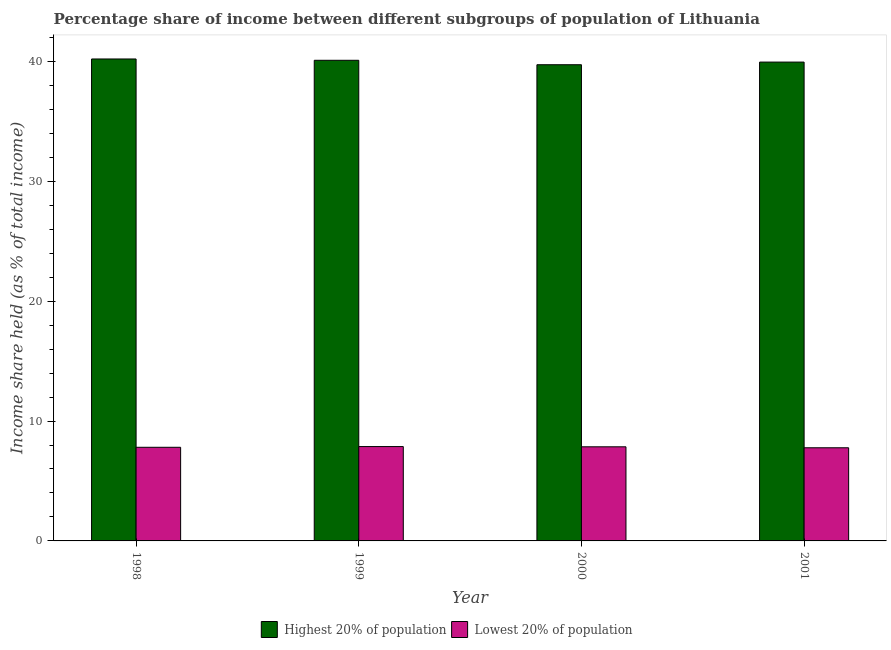How many different coloured bars are there?
Provide a succinct answer. 2. Are the number of bars per tick equal to the number of legend labels?
Make the answer very short. Yes. How many bars are there on the 4th tick from the left?
Give a very brief answer. 2. What is the label of the 2nd group of bars from the left?
Offer a very short reply. 1999. What is the income share held by highest 20% of the population in 1998?
Provide a succinct answer. 40.2. Across all years, what is the maximum income share held by lowest 20% of the population?
Your response must be concise. 7.87. Across all years, what is the minimum income share held by highest 20% of the population?
Make the answer very short. 39.72. In which year was the income share held by lowest 20% of the population maximum?
Keep it short and to the point. 1999. In which year was the income share held by highest 20% of the population minimum?
Make the answer very short. 2000. What is the total income share held by lowest 20% of the population in the graph?
Your answer should be compact. 31.3. What is the difference between the income share held by highest 20% of the population in 1999 and that in 2000?
Give a very brief answer. 0.37. What is the difference between the income share held by highest 20% of the population in 1998 and the income share held by lowest 20% of the population in 2000?
Give a very brief answer. 0.48. What is the average income share held by lowest 20% of the population per year?
Provide a succinct answer. 7.83. In how many years, is the income share held by highest 20% of the population greater than 34 %?
Ensure brevity in your answer.  4. What is the ratio of the income share held by highest 20% of the population in 1998 to that in 1999?
Offer a very short reply. 1. What is the difference between the highest and the second highest income share held by lowest 20% of the population?
Your response must be concise. 0.02. What is the difference between the highest and the lowest income share held by highest 20% of the population?
Give a very brief answer. 0.48. In how many years, is the income share held by lowest 20% of the population greater than the average income share held by lowest 20% of the population taken over all years?
Provide a succinct answer. 2. What does the 1st bar from the left in 2000 represents?
Your answer should be compact. Highest 20% of population. What does the 2nd bar from the right in 2000 represents?
Provide a succinct answer. Highest 20% of population. How many bars are there?
Your response must be concise. 8. Are all the bars in the graph horizontal?
Keep it short and to the point. No. How many years are there in the graph?
Your answer should be compact. 4. Where does the legend appear in the graph?
Provide a succinct answer. Bottom center. How many legend labels are there?
Offer a terse response. 2. What is the title of the graph?
Your answer should be compact. Percentage share of income between different subgroups of population of Lithuania. Does "Merchandise imports" appear as one of the legend labels in the graph?
Offer a very short reply. No. What is the label or title of the Y-axis?
Your answer should be very brief. Income share held (as % of total income). What is the Income share held (as % of total income) in Highest 20% of population in 1998?
Your answer should be compact. 40.2. What is the Income share held (as % of total income) of Lowest 20% of population in 1998?
Ensure brevity in your answer.  7.81. What is the Income share held (as % of total income) of Highest 20% of population in 1999?
Ensure brevity in your answer.  40.09. What is the Income share held (as % of total income) of Lowest 20% of population in 1999?
Your answer should be very brief. 7.87. What is the Income share held (as % of total income) in Highest 20% of population in 2000?
Your response must be concise. 39.72. What is the Income share held (as % of total income) in Lowest 20% of population in 2000?
Keep it short and to the point. 7.85. What is the Income share held (as % of total income) in Highest 20% of population in 2001?
Ensure brevity in your answer.  39.94. What is the Income share held (as % of total income) in Lowest 20% of population in 2001?
Offer a terse response. 7.77. Across all years, what is the maximum Income share held (as % of total income) in Highest 20% of population?
Your answer should be compact. 40.2. Across all years, what is the maximum Income share held (as % of total income) of Lowest 20% of population?
Keep it short and to the point. 7.87. Across all years, what is the minimum Income share held (as % of total income) of Highest 20% of population?
Ensure brevity in your answer.  39.72. Across all years, what is the minimum Income share held (as % of total income) of Lowest 20% of population?
Provide a succinct answer. 7.77. What is the total Income share held (as % of total income) in Highest 20% of population in the graph?
Your response must be concise. 159.95. What is the total Income share held (as % of total income) of Lowest 20% of population in the graph?
Provide a succinct answer. 31.3. What is the difference between the Income share held (as % of total income) in Highest 20% of population in 1998 and that in 1999?
Your answer should be very brief. 0.11. What is the difference between the Income share held (as % of total income) of Lowest 20% of population in 1998 and that in 1999?
Make the answer very short. -0.06. What is the difference between the Income share held (as % of total income) of Highest 20% of population in 1998 and that in 2000?
Offer a very short reply. 0.48. What is the difference between the Income share held (as % of total income) of Lowest 20% of population in 1998 and that in 2000?
Provide a short and direct response. -0.04. What is the difference between the Income share held (as % of total income) in Highest 20% of population in 1998 and that in 2001?
Offer a terse response. 0.26. What is the difference between the Income share held (as % of total income) in Lowest 20% of population in 1998 and that in 2001?
Your response must be concise. 0.04. What is the difference between the Income share held (as % of total income) in Highest 20% of population in 1999 and that in 2000?
Your answer should be compact. 0.37. What is the difference between the Income share held (as % of total income) in Lowest 20% of population in 1999 and that in 2000?
Your response must be concise. 0.02. What is the difference between the Income share held (as % of total income) in Highest 20% of population in 1999 and that in 2001?
Make the answer very short. 0.15. What is the difference between the Income share held (as % of total income) in Lowest 20% of population in 1999 and that in 2001?
Provide a short and direct response. 0.1. What is the difference between the Income share held (as % of total income) in Highest 20% of population in 2000 and that in 2001?
Your answer should be very brief. -0.22. What is the difference between the Income share held (as % of total income) of Highest 20% of population in 1998 and the Income share held (as % of total income) of Lowest 20% of population in 1999?
Your answer should be very brief. 32.33. What is the difference between the Income share held (as % of total income) in Highest 20% of population in 1998 and the Income share held (as % of total income) in Lowest 20% of population in 2000?
Your answer should be compact. 32.35. What is the difference between the Income share held (as % of total income) in Highest 20% of population in 1998 and the Income share held (as % of total income) in Lowest 20% of population in 2001?
Give a very brief answer. 32.43. What is the difference between the Income share held (as % of total income) in Highest 20% of population in 1999 and the Income share held (as % of total income) in Lowest 20% of population in 2000?
Provide a short and direct response. 32.24. What is the difference between the Income share held (as % of total income) in Highest 20% of population in 1999 and the Income share held (as % of total income) in Lowest 20% of population in 2001?
Offer a terse response. 32.32. What is the difference between the Income share held (as % of total income) in Highest 20% of population in 2000 and the Income share held (as % of total income) in Lowest 20% of population in 2001?
Provide a succinct answer. 31.95. What is the average Income share held (as % of total income) in Highest 20% of population per year?
Give a very brief answer. 39.99. What is the average Income share held (as % of total income) in Lowest 20% of population per year?
Your answer should be compact. 7.83. In the year 1998, what is the difference between the Income share held (as % of total income) in Highest 20% of population and Income share held (as % of total income) in Lowest 20% of population?
Your answer should be compact. 32.39. In the year 1999, what is the difference between the Income share held (as % of total income) in Highest 20% of population and Income share held (as % of total income) in Lowest 20% of population?
Your answer should be very brief. 32.22. In the year 2000, what is the difference between the Income share held (as % of total income) of Highest 20% of population and Income share held (as % of total income) of Lowest 20% of population?
Your answer should be compact. 31.87. In the year 2001, what is the difference between the Income share held (as % of total income) of Highest 20% of population and Income share held (as % of total income) of Lowest 20% of population?
Offer a terse response. 32.17. What is the ratio of the Income share held (as % of total income) of Lowest 20% of population in 1998 to that in 1999?
Your answer should be compact. 0.99. What is the ratio of the Income share held (as % of total income) of Highest 20% of population in 1998 to that in 2000?
Your answer should be very brief. 1.01. What is the ratio of the Income share held (as % of total income) in Highest 20% of population in 1998 to that in 2001?
Keep it short and to the point. 1.01. What is the ratio of the Income share held (as % of total income) in Highest 20% of population in 1999 to that in 2000?
Provide a succinct answer. 1.01. What is the ratio of the Income share held (as % of total income) of Lowest 20% of population in 1999 to that in 2001?
Your answer should be very brief. 1.01. What is the ratio of the Income share held (as % of total income) in Lowest 20% of population in 2000 to that in 2001?
Offer a very short reply. 1.01. What is the difference between the highest and the second highest Income share held (as % of total income) in Highest 20% of population?
Make the answer very short. 0.11. What is the difference between the highest and the lowest Income share held (as % of total income) in Highest 20% of population?
Your response must be concise. 0.48. What is the difference between the highest and the lowest Income share held (as % of total income) of Lowest 20% of population?
Ensure brevity in your answer.  0.1. 